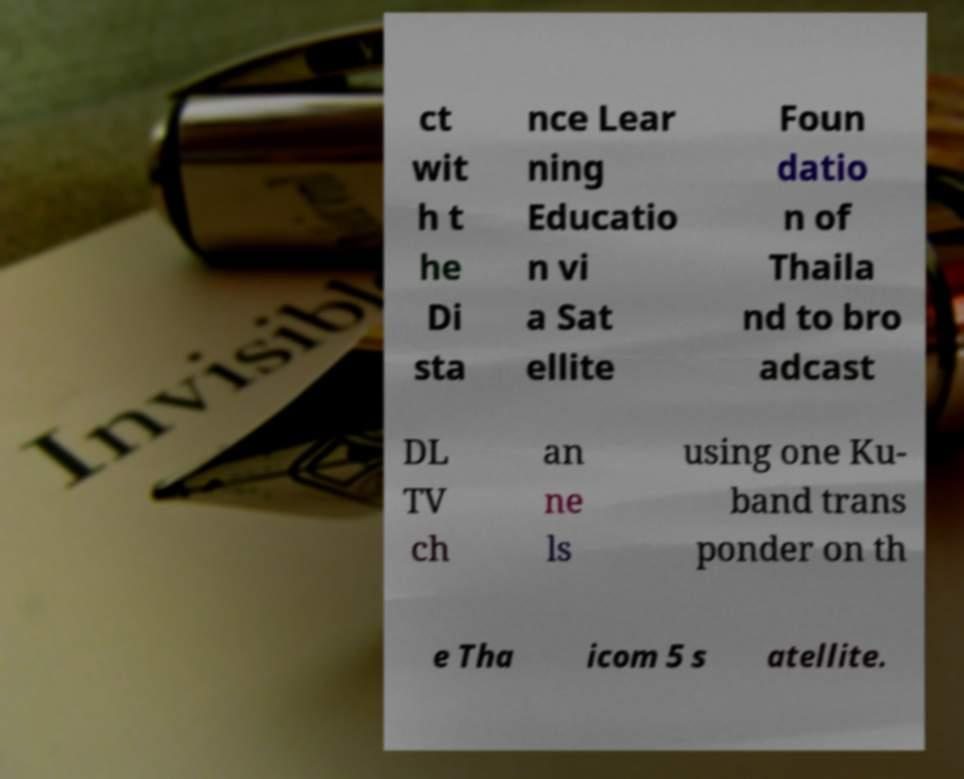Could you assist in decoding the text presented in this image and type it out clearly? ct wit h t he Di sta nce Lear ning Educatio n vi a Sat ellite Foun datio n of Thaila nd to bro adcast DL TV ch an ne ls using one Ku- band trans ponder on th e Tha icom 5 s atellite. 